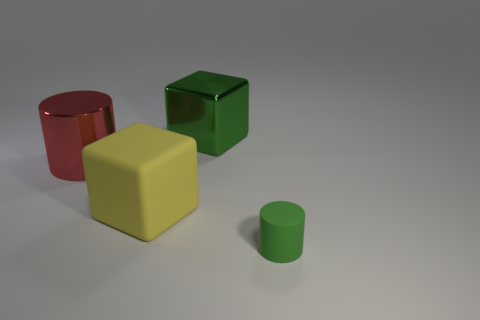Is there anything else that has the same size as the red metallic cylinder?
Offer a very short reply. Yes. How many tiny cylinders have the same color as the large shiny cube?
Give a very brief answer. 1. There is a small thing; does it have the same color as the cube behind the large red metal cylinder?
Provide a succinct answer. Yes. Do the tiny green cylinder and the big cube left of the large green metallic thing have the same material?
Make the answer very short. Yes. Are there an equal number of large red things to the right of the big red object and green shiny objects that are in front of the green rubber thing?
Offer a terse response. Yes. What material is the tiny green object?
Offer a terse response. Rubber. What color is the cube that is the same size as the green metal thing?
Your answer should be compact. Yellow. Is there a big cylinder that is to the right of the block left of the green shiny block?
Provide a succinct answer. No. How many cylinders are either green objects or large red things?
Offer a terse response. 2. What is the size of the cylinder that is on the right side of the large object in front of the cylinder that is behind the rubber cylinder?
Ensure brevity in your answer.  Small. 